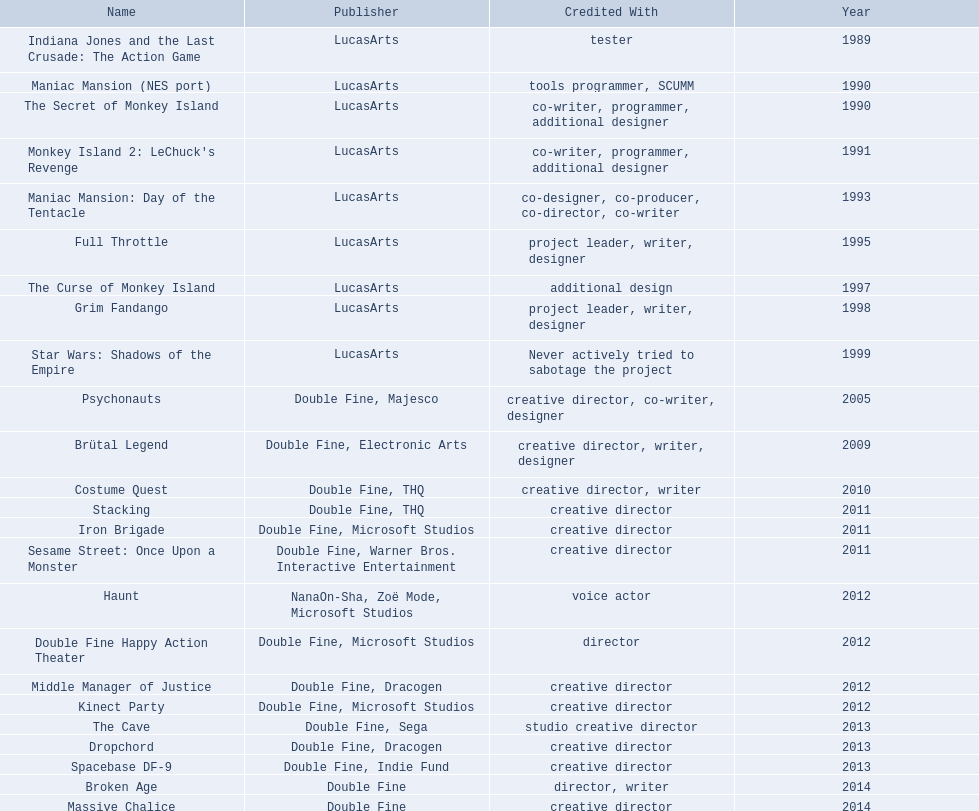Which game is credited with a creative director? Creative director, co-writer, designer, creative director, writer, designer, creative director, writer, creative director, creative director, creative director, creative director, creative director, creative director, creative director, creative director. Of these games, which also has warner bros. interactive listed as creative director? Sesame Street: Once Upon a Monster. 